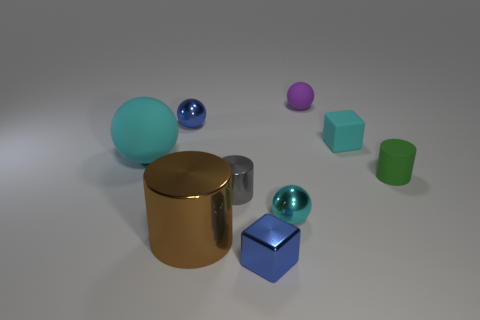What material is the sphere that is the same color as the tiny metal block?
Your response must be concise. Metal. What is the material of the blue object that is the same shape as the large cyan thing?
Give a very brief answer. Metal. There is a rubber object that is left of the gray thing; is it the same size as the small purple ball?
Ensure brevity in your answer.  No. What is the size of the object that is both to the left of the big brown metal object and behind the large cyan ball?
Keep it short and to the point. Small. What number of gray metal things have the same size as the cyan shiny ball?
Offer a terse response. 1. How many blue things are behind the matte thing that is on the left side of the small blue block?
Provide a short and direct response. 1. Is the color of the small sphere on the left side of the cyan metallic thing the same as the metal cube?
Your answer should be very brief. Yes. Are there any cyan rubber things that are left of the cyan object that is in front of the rubber sphere left of the brown cylinder?
Give a very brief answer. Yes. What is the shape of the small object that is in front of the large rubber thing and behind the small gray shiny cylinder?
Offer a terse response. Cylinder. Are there any large matte things that have the same color as the large shiny thing?
Provide a succinct answer. No. 